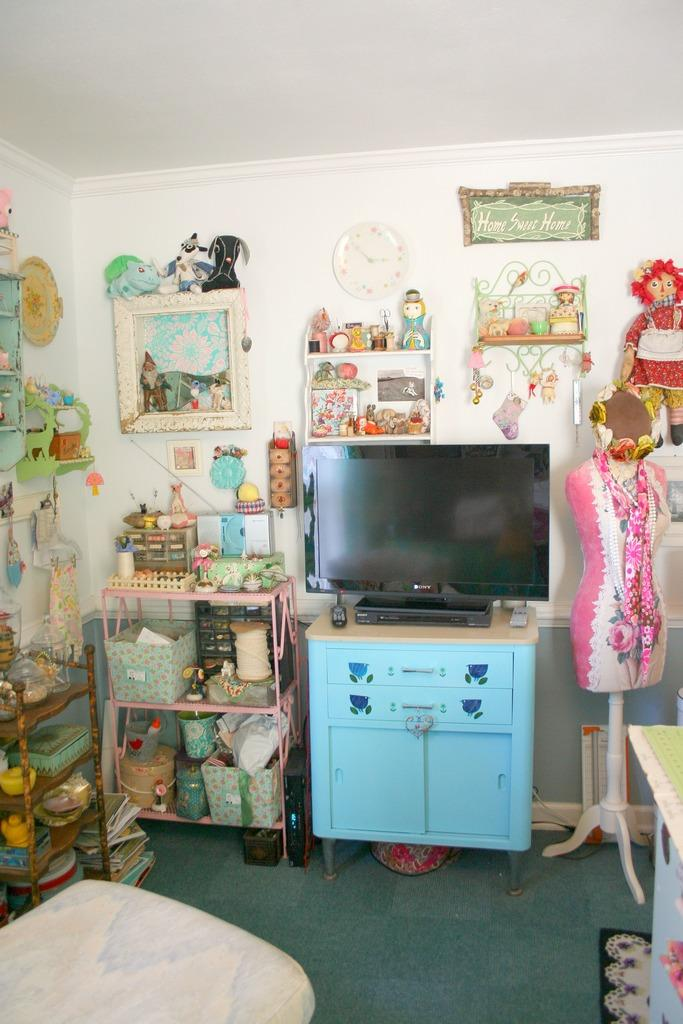<image>
Offer a succinct explanation of the picture presented. A room has a "home sweet home" sign on the wall. 